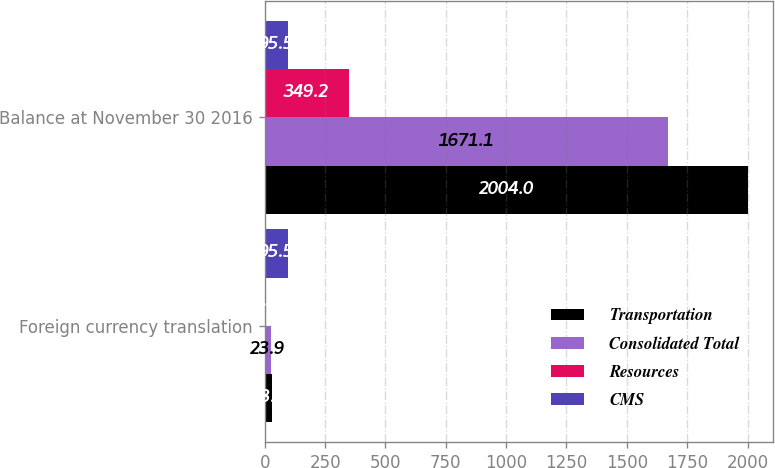Convert chart. <chart><loc_0><loc_0><loc_500><loc_500><stacked_bar_chart><ecel><fcel>Foreign currency translation<fcel>Balance at November 30 2016<nl><fcel>Transportation<fcel>28.6<fcel>2004<nl><fcel>Consolidated Total<fcel>23.9<fcel>1671.1<nl><fcel>Resources<fcel>5.1<fcel>349.2<nl><fcel>CMS<fcel>95.5<fcel>95.5<nl></chart> 